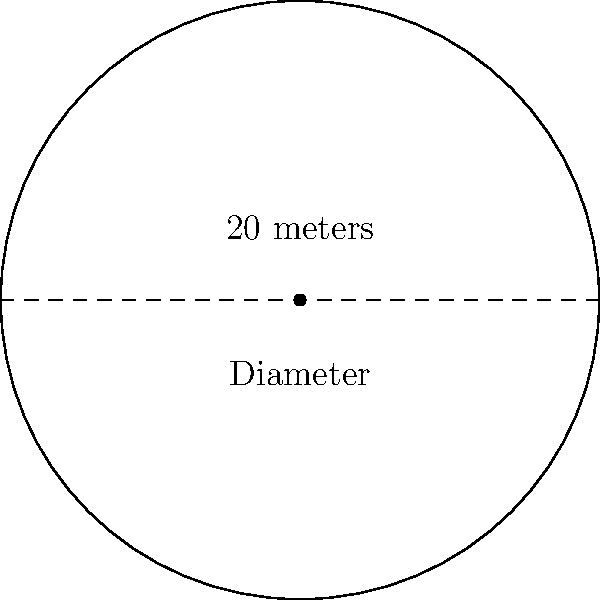The village green in Wickhamford is perfectly circular. If its diameter measures 20 meters, what is the approximate circumference of the green? To find the circumference of the circular village green, we can follow these steps:

1) Recall the formula for the circumference of a circle: $C = \pi d$, where $C$ is the circumference, $\pi$ is pi, and $d$ is the diameter.

2) We're given that the diameter is 20 meters.

3) Substitute the known values into the formula:
   $C = \pi \times 20$

4) $\pi$ is approximately equal to 3.14159. For practical purposes, we can round it to 3.14.

5) Calculate:
   $C \approx 3.14 \times 20 = 62.8$ meters

6) Round to a reasonable precision for a village green measurement:
   $C \approx 63$ meters

Therefore, the approximate circumference of the Wickhamford village green is 63 meters.
Answer: 63 meters 